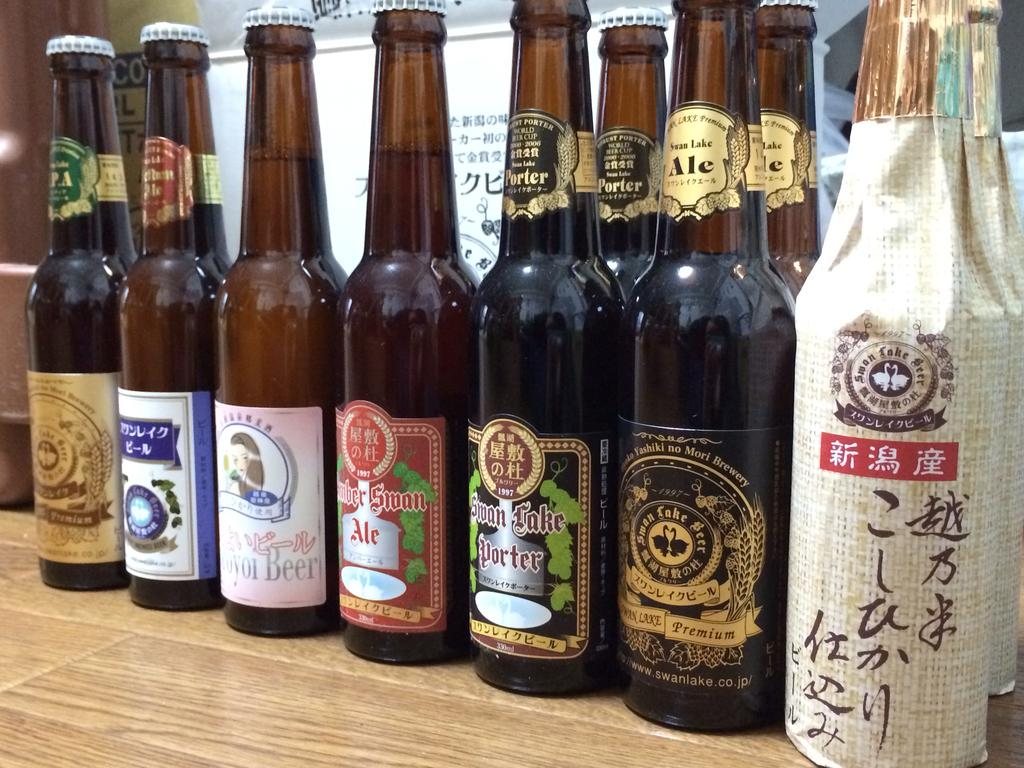<image>
Provide a brief description of the given image. many beer bottles and one with the word swan on it 